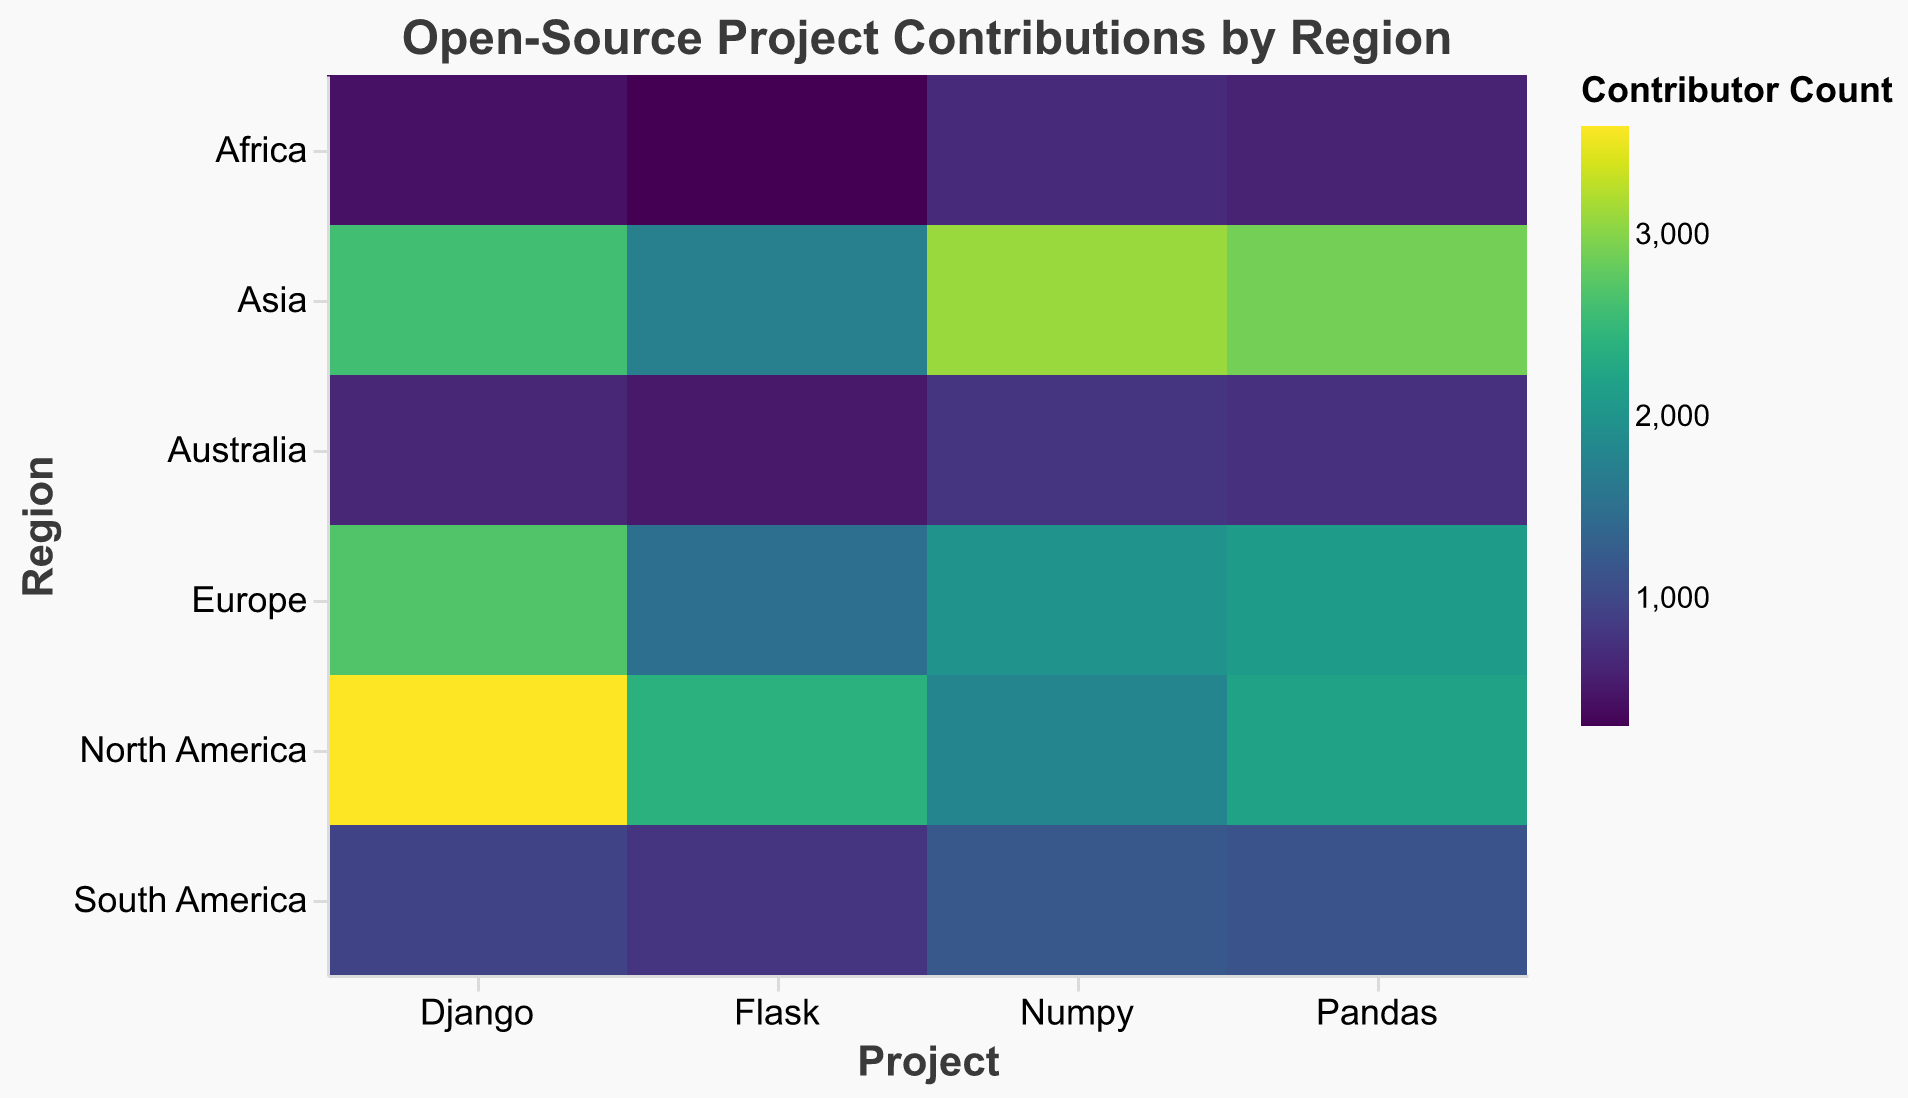What is the title of the heatmap? The title of the heatmap is displayed at the top. It reads "Open-Source Project Contributions by Region."
Answer: Open-Source Project Contributions by Region Which region has the highest number of contributors for Django? By looking at the darkest cell in the row corresponding to "Django," we can see that North America has the highest number of contributors.
Answer: North America How many contributors are there for Pandas in Europe? By locating the cell at the intersection of the "Europe" row and "Pandas" column, the tooltip or color gradient indicates the number of contributors, which is 2100.
Answer: 2100 What is the sum of contributors for Numpy across all regions? Sum the contributor counts for Numpy from all regions: 1800 (North America) + 2000 (Europe) + 3100 (Asia) + 1200 (South America) + 700 (Africa) + 800 (Australia) = 9600.
Answer: 9600 Which project has the least contributors in Africa? By checking the cells in the "Africa" row, the project with the lightest color, representing the lowest number, is Flask with 300 contributors.
Answer: Flask Compare the number of contributors for Flask in North America and Australia. Which region has more contributors? By comparing the cells in the "Flask" column for North America and Australia, North America has 2400 contributors, while Australia has 500. North America has more contributors.
Answer: North America What is the average number of contributors for Django across all regions? Calculate the average by summing the contributor counts for Django and dividing by the total number of regions: (3600 + 2700 + 2600 + 950 + 450 + 650) / 6 = 10950 / 6 = 1825 contributors.
Answer: 1825 Which region has the most balanced contribution numbers across all projects? The region where the colors are most similar in hue across the row, indicating more balanced contributions, is Europe.
Answer: Europe Considering all projects, which region seems to have the most contributors overall? Visually inspect the overall darkness of the cells in each row; North America and Asia appear darker, indicating higher contributions. Summing the totals confirms North America has more overall contributors.
Answer: North America Does South America have more contributors for any project compared to Africa? If so, for which project(s)? Compare the cells for South America and Africa in each project column. South America has more contributors for Flask (800 vs 300), Django (950 vs 450), Numpy (1200 vs 700), and Pandas (1150 vs 600).
Answer: Flask, Django, Numpy, Pandas 